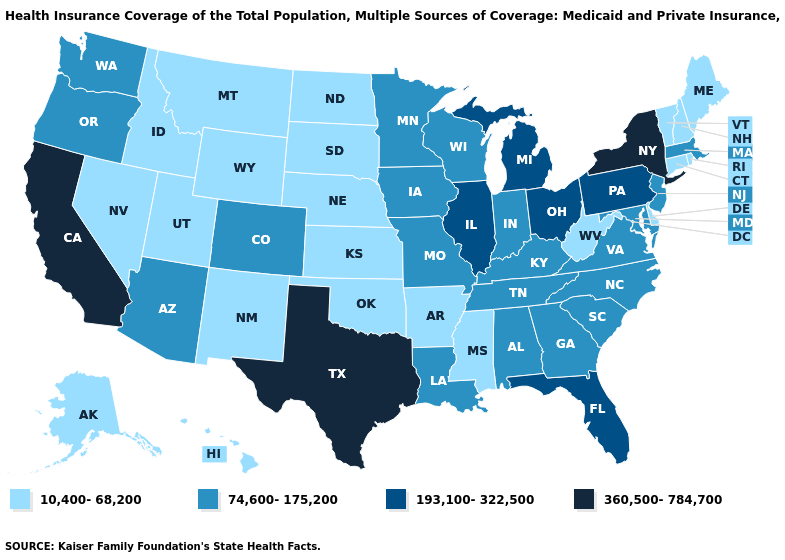Among the states that border Montana , which have the highest value?
Be succinct. Idaho, North Dakota, South Dakota, Wyoming. What is the value of Louisiana?
Be succinct. 74,600-175,200. What is the value of Connecticut?
Be succinct. 10,400-68,200. What is the value of Illinois?
Quick response, please. 193,100-322,500. What is the value of North Carolina?
Concise answer only. 74,600-175,200. What is the highest value in states that border Minnesota?
Keep it brief. 74,600-175,200. Name the states that have a value in the range 360,500-784,700?
Keep it brief. California, New York, Texas. Does North Dakota have the lowest value in the USA?
Concise answer only. Yes. How many symbols are there in the legend?
Concise answer only. 4. Which states have the lowest value in the MidWest?
Quick response, please. Kansas, Nebraska, North Dakota, South Dakota. What is the value of Utah?
Quick response, please. 10,400-68,200. Does the first symbol in the legend represent the smallest category?
Answer briefly. Yes. Which states have the highest value in the USA?
Write a very short answer. California, New York, Texas. Name the states that have a value in the range 10,400-68,200?
Write a very short answer. Alaska, Arkansas, Connecticut, Delaware, Hawaii, Idaho, Kansas, Maine, Mississippi, Montana, Nebraska, Nevada, New Hampshire, New Mexico, North Dakota, Oklahoma, Rhode Island, South Dakota, Utah, Vermont, West Virginia, Wyoming. Name the states that have a value in the range 74,600-175,200?
Keep it brief. Alabama, Arizona, Colorado, Georgia, Indiana, Iowa, Kentucky, Louisiana, Maryland, Massachusetts, Minnesota, Missouri, New Jersey, North Carolina, Oregon, South Carolina, Tennessee, Virginia, Washington, Wisconsin. 